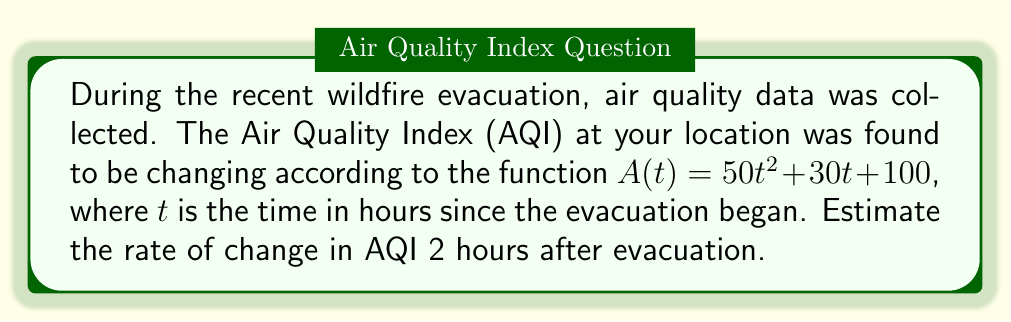Teach me how to tackle this problem. To estimate the rate of change in AQI at a specific time, we need to find the derivative of the given function and evaluate it at the given time.

1) The given function is $A(t) = 50t^2 + 30t + 100$

2) To find the derivative, we use the power rule and constant rule:
   $$\frac{dA}{dt} = 100t + 30$$

3) We're asked to estimate the rate of change 2 hours after evacuation, so we need to evaluate $\frac{dA}{dt}$ at $t = 2$:

   $$\frac{dA}{dt}|_{t=2} = 100(2) + 30 = 200 + 30 = 230$$

4) The units for this rate of change would be AQI per hour.

Therefore, 2 hours after evacuation, the AQI is estimated to be increasing at a rate of 230 units per hour.
Answer: 230 AQI/hour 